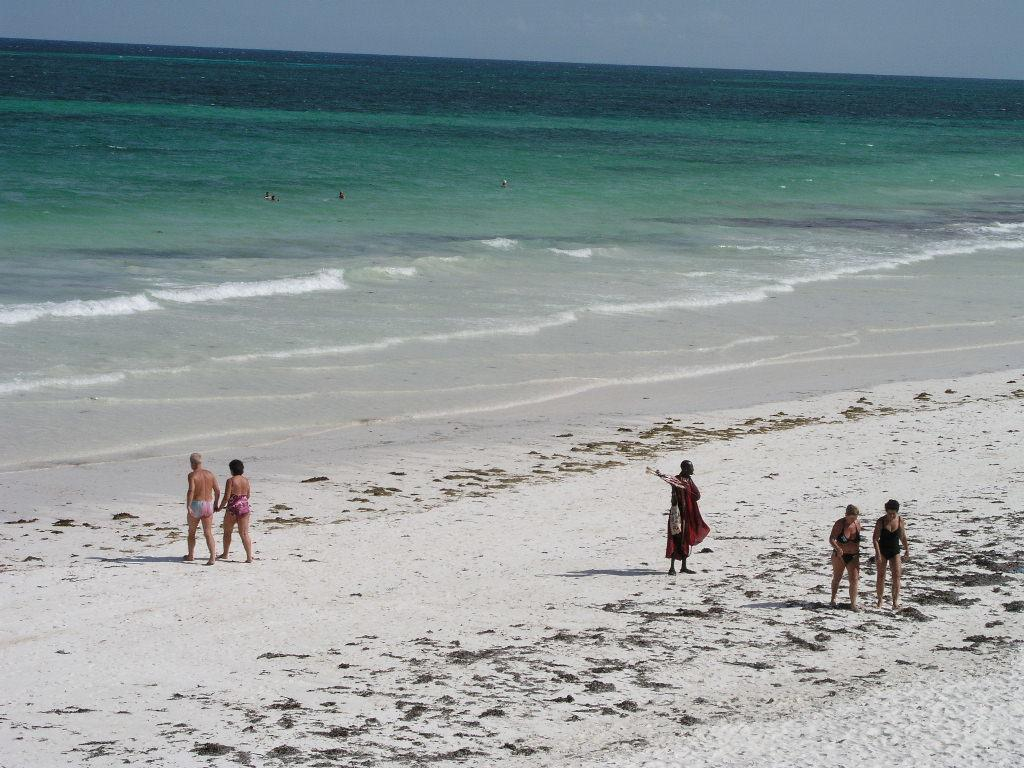What is the main setting of the image? The main setting of the image is the seashore. What can be seen in the sky in the image? The sky is visible in the image. Can you describe the activities of the people in the image? There is a group of people on the seashore, and there are also people in a large water body. What type of thread is being used to create the border in the image? There is no border present in the image, and therefore no thread can be observed. 